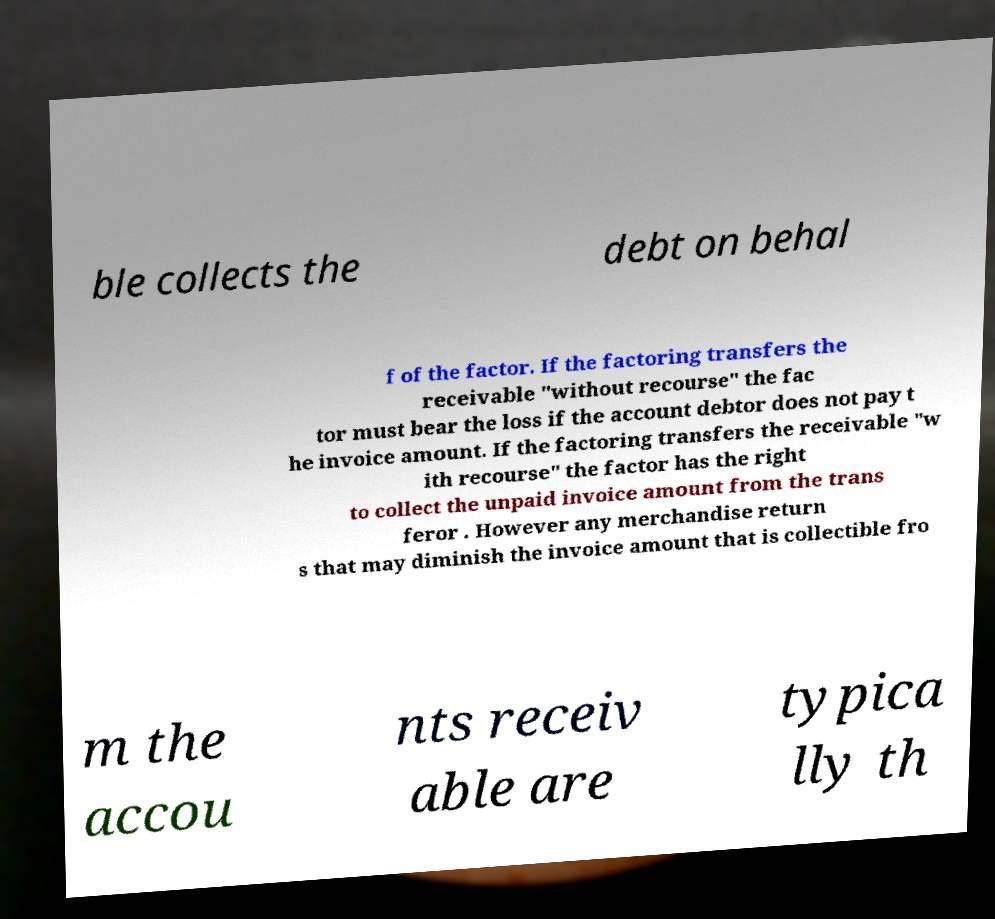Could you extract and type out the text from this image? ble collects the debt on behal f of the factor. If the factoring transfers the receivable "without recourse" the fac tor must bear the loss if the account debtor does not pay t he invoice amount. If the factoring transfers the receivable "w ith recourse" the factor has the right to collect the unpaid invoice amount from the trans feror . However any merchandise return s that may diminish the invoice amount that is collectible fro m the accou nts receiv able are typica lly th 